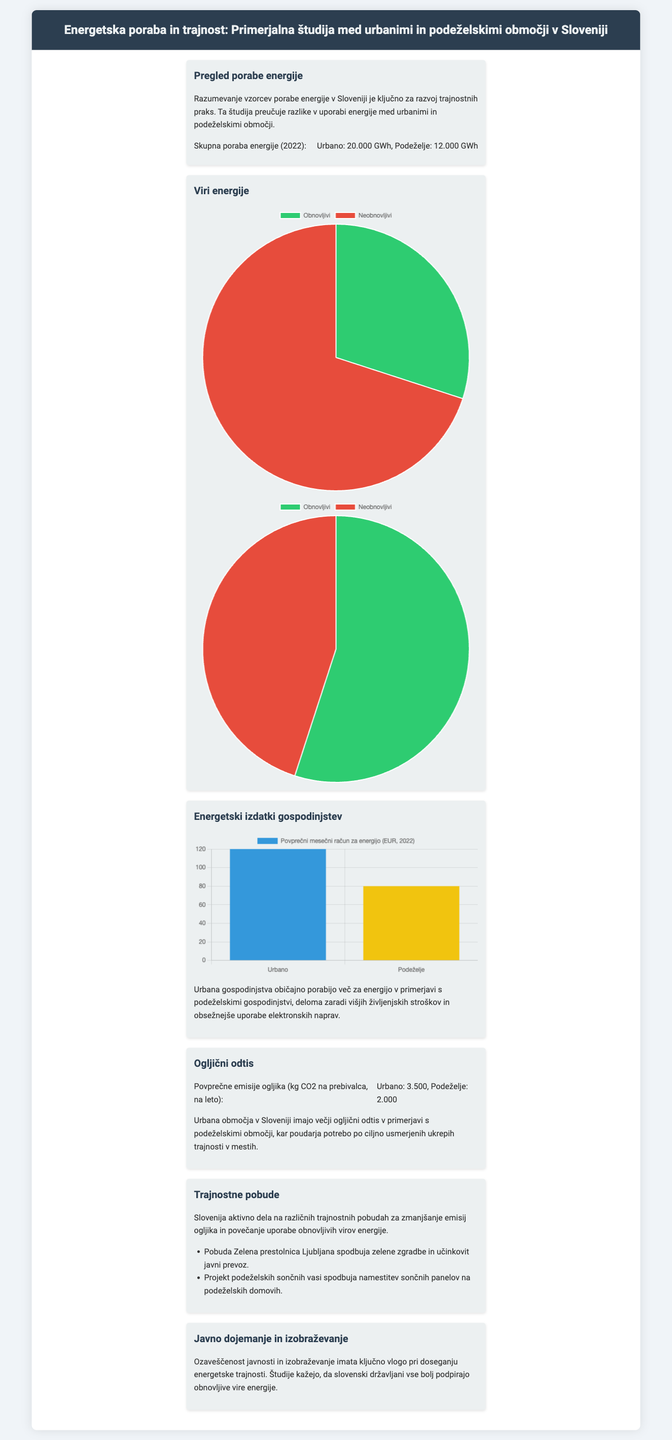what is the total energy consumption in urban areas in 2022? The total energy consumption in urban areas is indicated as 20,000 GWh in the document.
Answer: 20,000 GWh what is the total energy consumption in rural areas in 2022? The total energy consumption in rural areas is indicated as 12,000 GWh in the document.
Answer: 12,000 GWh what is the average monthly energy bill for urban households? The average monthly energy bill for urban households is stated as 120 EUR in the document.
Answer: 120 EUR what is the average monthly energy bill for rural households? The average monthly energy bill for rural households is stated as 80 EUR in the document.
Answer: 80 EUR what is the average carbon emissions per capita in urban areas? The average carbon emissions per capita in urban areas is indicated as 3,500 kg CO2 per year in the document.
Answer: 3,500 kg what is the average carbon emissions per capita in rural areas? The average carbon emissions per capita in rural areas is indicated as 2,000 kg CO2 per year in the document.
Answer: 2,000 kg what percentage of energy sources in urban areas are renewable? The percentage of renewable energy sources in urban areas is shown as 30% according to the pie chart in the document.
Answer: 30% what percentage of energy sources in rural areas are renewable? The percentage of renewable energy sources in rural areas is shown as 55% according to the pie chart in the document.
Answer: 55% what initiative promotes solar panel installation in rural areas? The initiative promoting solar panel installation in rural areas is mentioned as "Projekt podeželskih sončnih vasi" in the document.
Answer: Projekt podeželskih sončnih vasi 